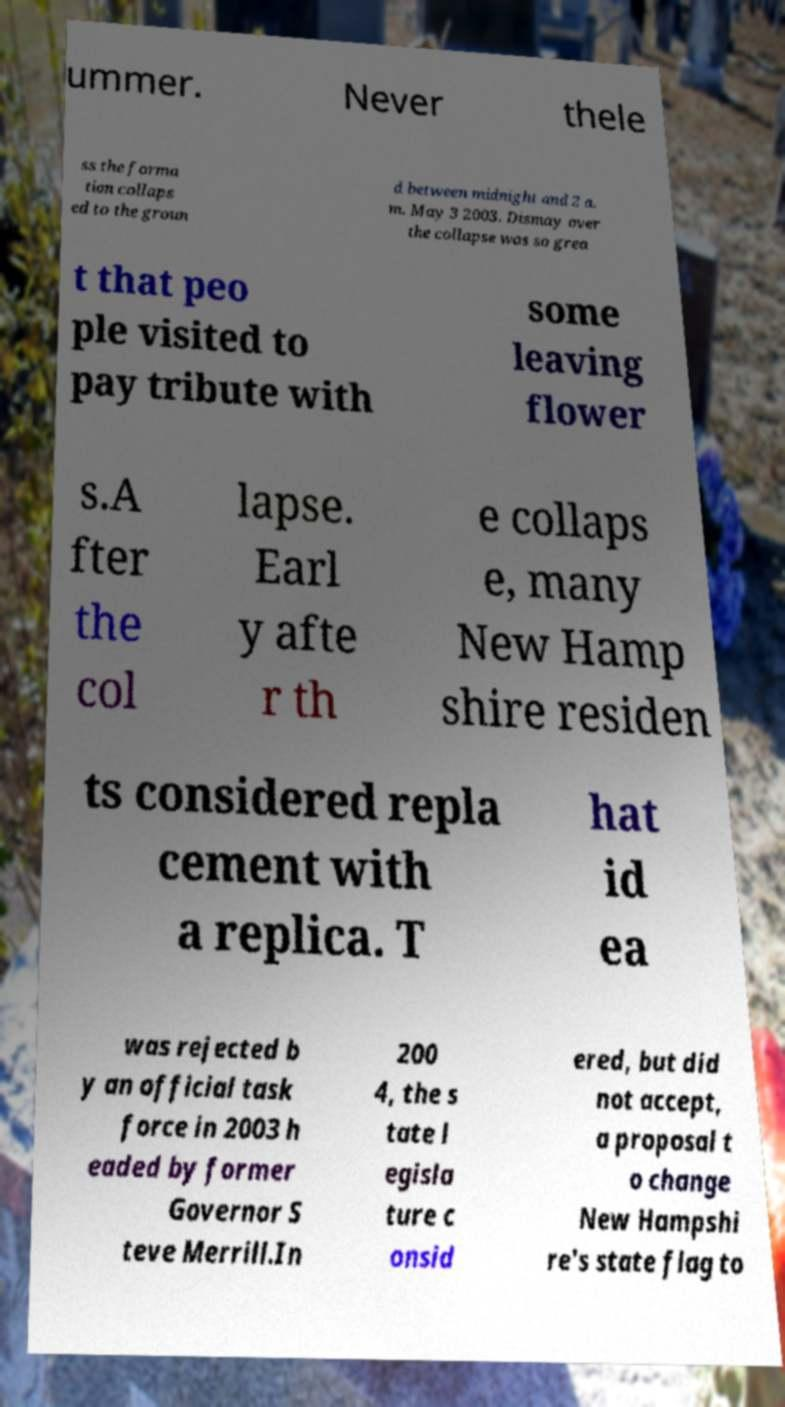I need the written content from this picture converted into text. Can you do that? ummer. Never thele ss the forma tion collaps ed to the groun d between midnight and 2 a. m. May 3 2003. Dismay over the collapse was so grea t that peo ple visited to pay tribute with some leaving flower s.A fter the col lapse. Earl y afte r th e collaps e, many New Hamp shire residen ts considered repla cement with a replica. T hat id ea was rejected b y an official task force in 2003 h eaded by former Governor S teve Merrill.In 200 4, the s tate l egisla ture c onsid ered, but did not accept, a proposal t o change New Hampshi re's state flag to 